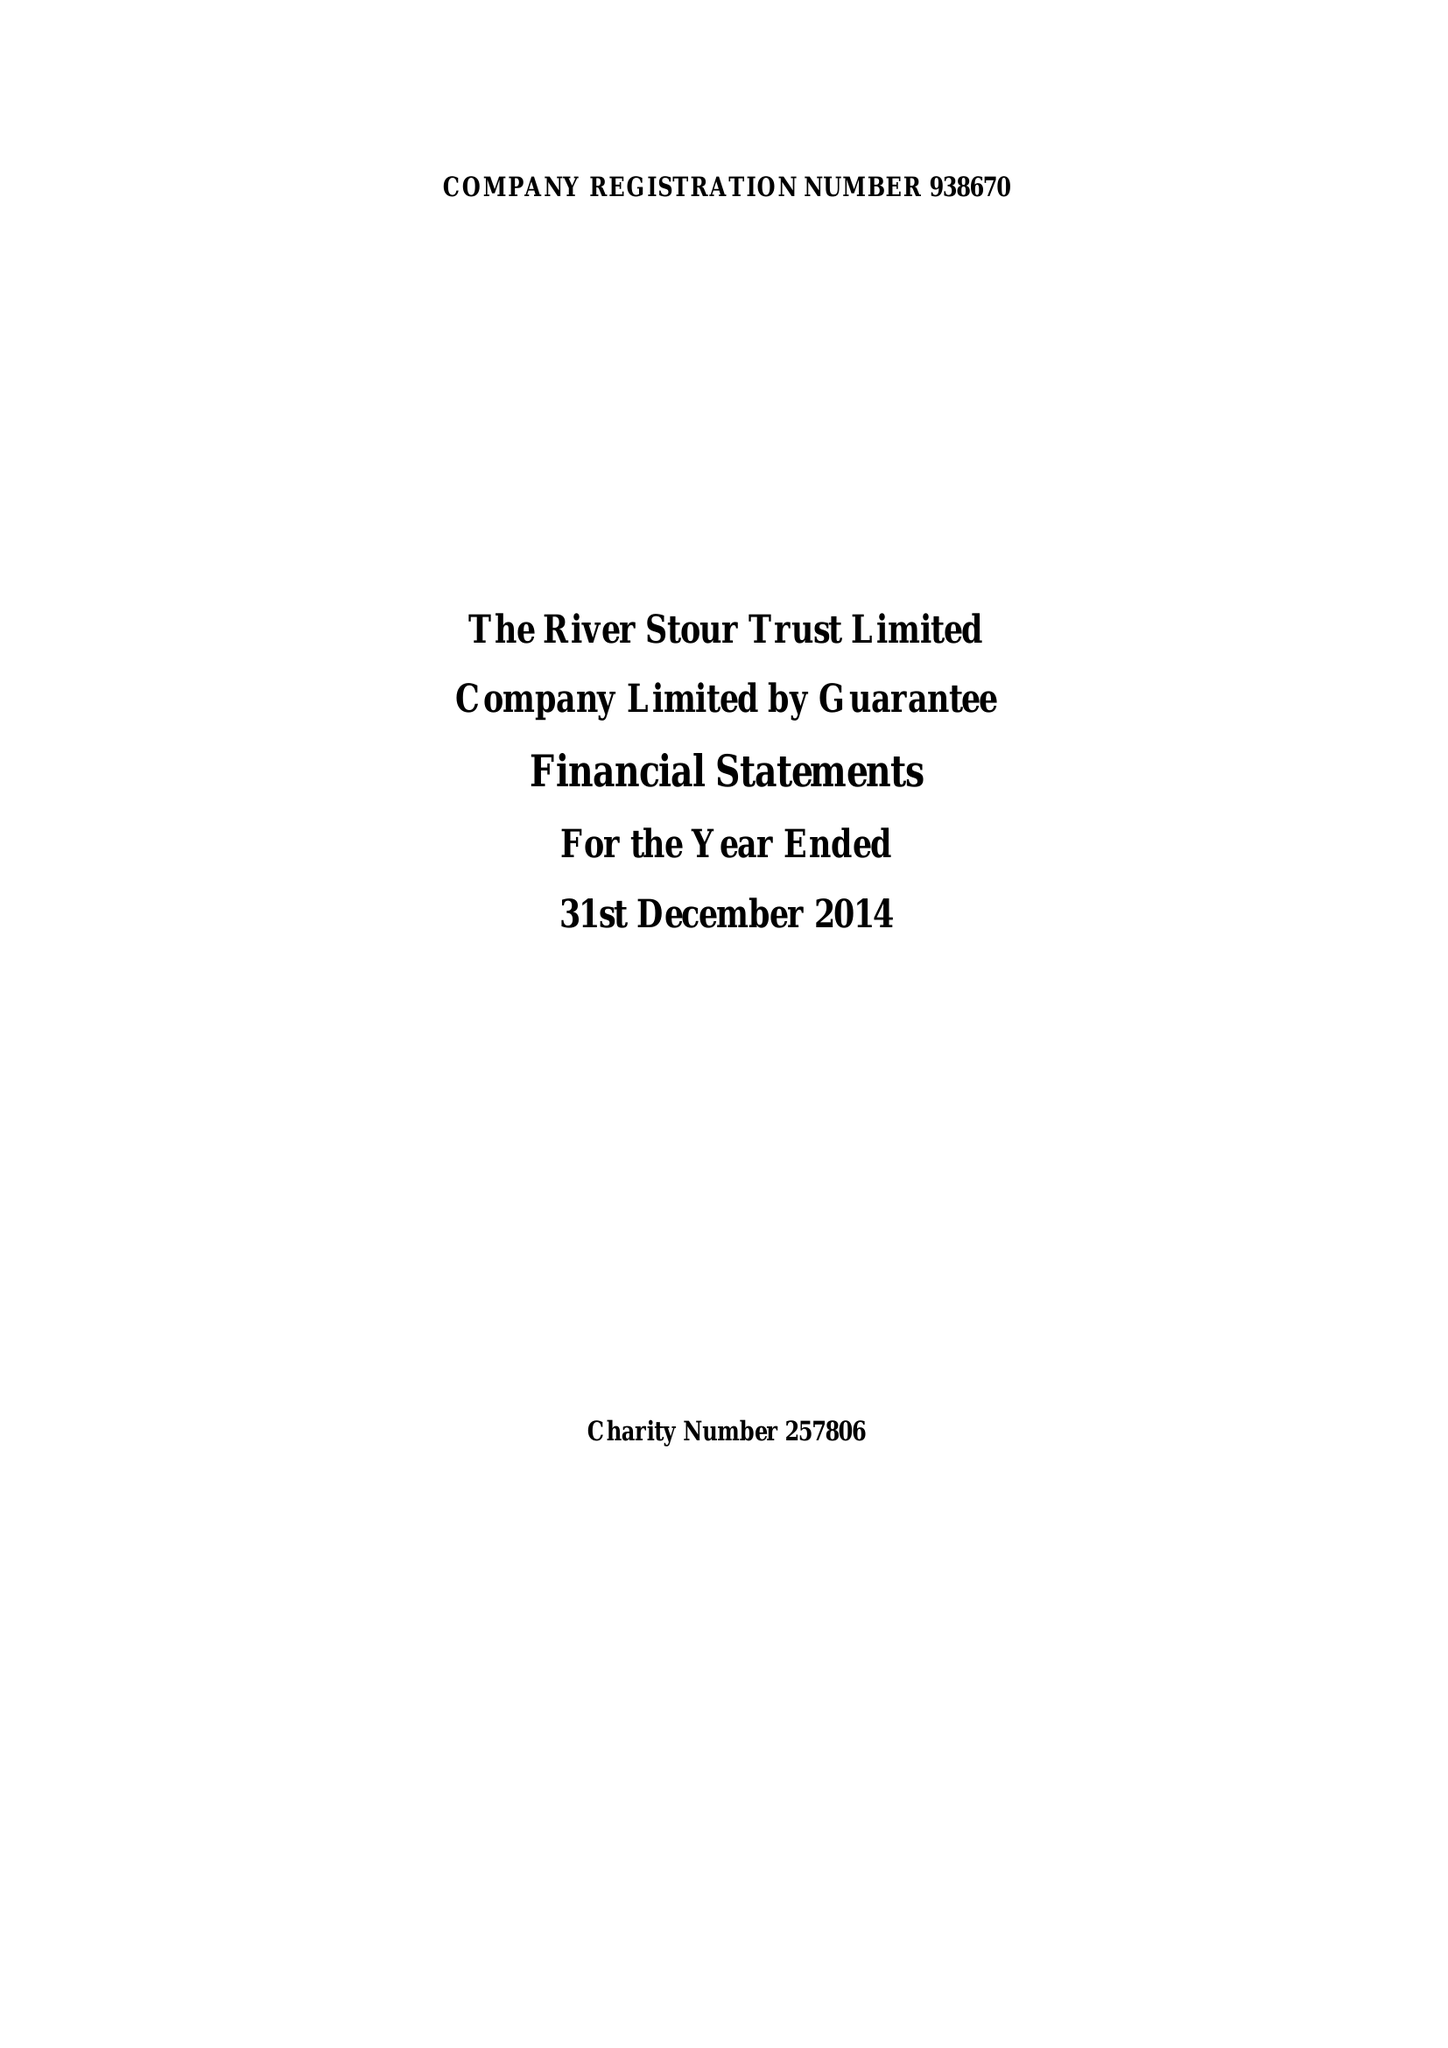What is the value for the charity_number?
Answer the question using a single word or phrase. 257806 